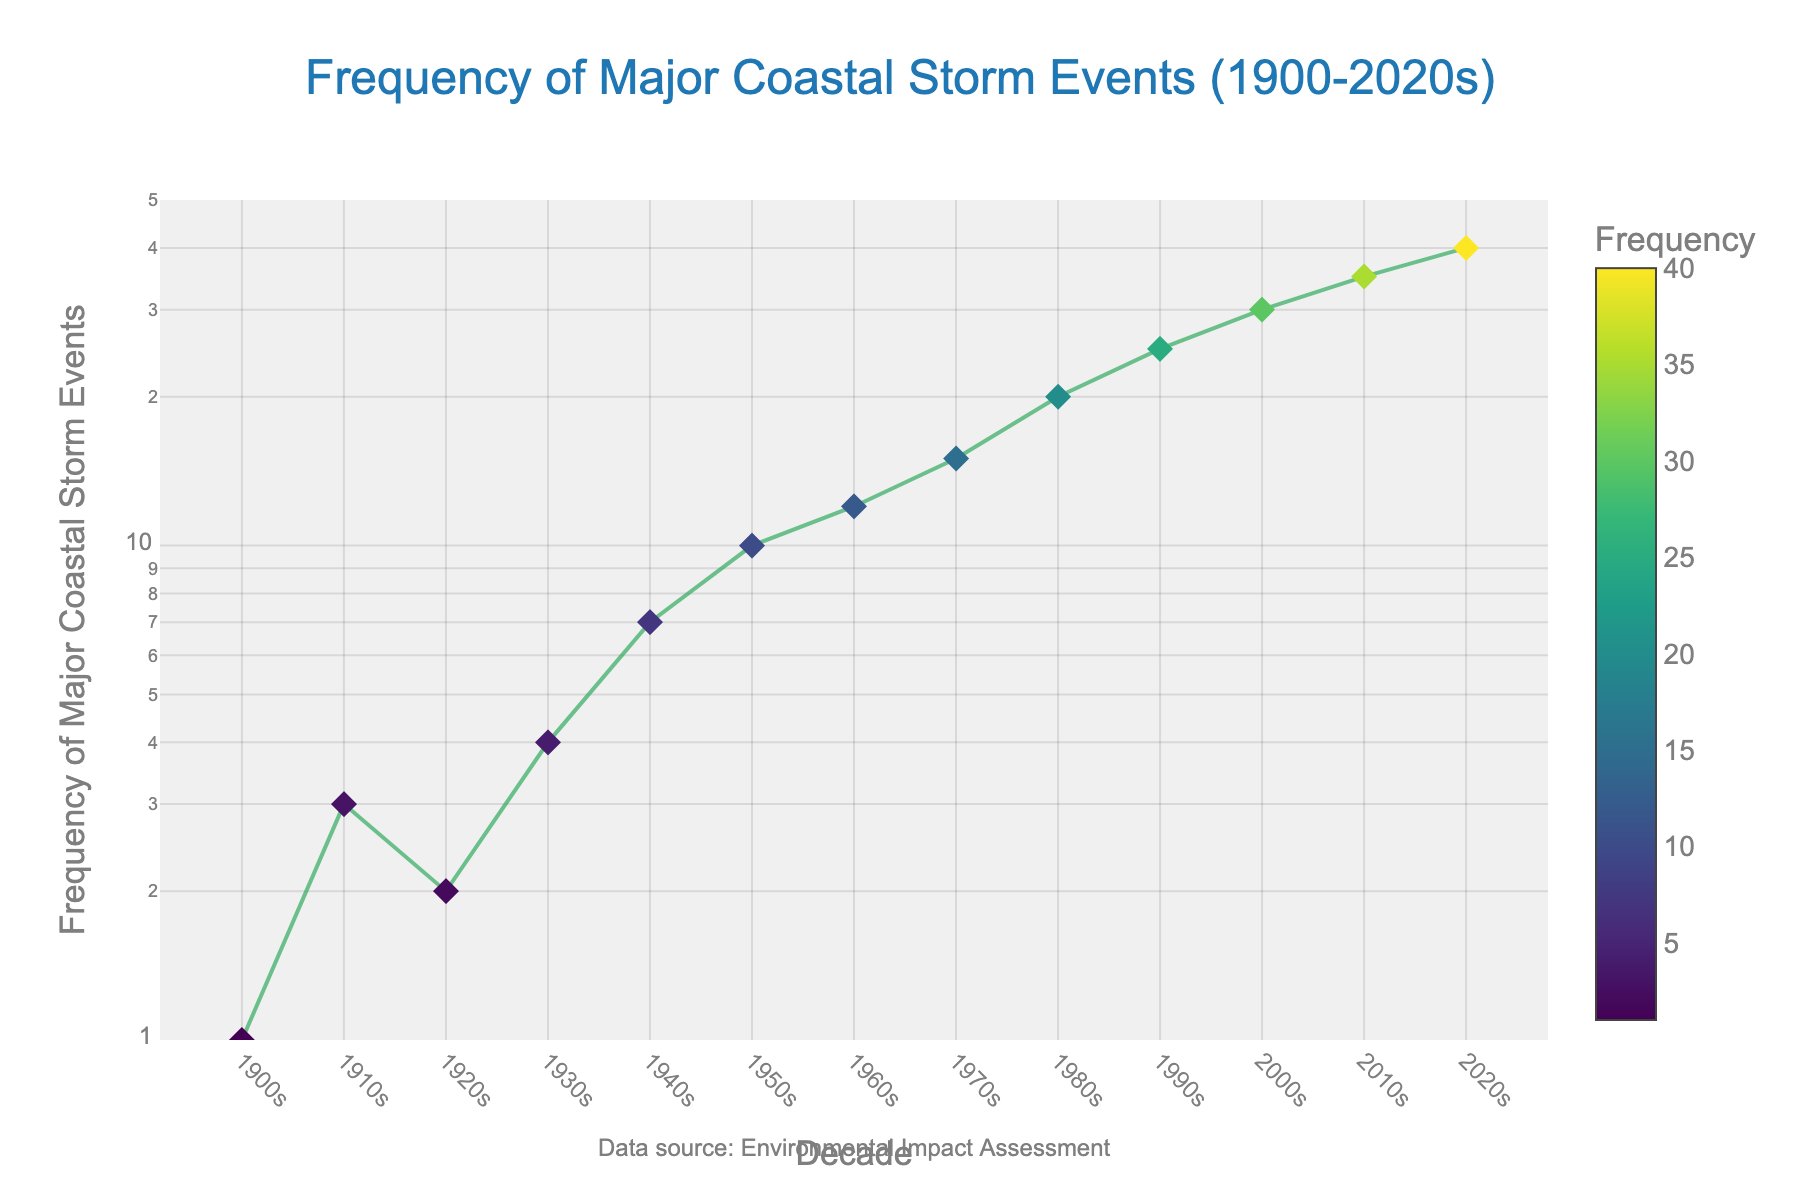How many decades are represented in the figure? There are 13 points on the x-axis, each representing a decade from the 1900s to the 2020s.
Answer: 13 What is the title of the figure? The title is at the top of the plot in a larger font.
Answer: Frequency of Major Coastal Storm Events (1900-2020s) How many storm events were recorded in the 1970s? By looking at the y-value corresponding to the x-value for the 1970s, you can see it is 15.
Answer: 15 In which decade did the frequency of major storm events first reach double digits? The frequency reaches 10 in the 1950s, as indicated by the y-value for that decade.
Answer: 1950s What is the color scheme used for the markers? The color scheme is a Viridis color scale, which is apparent from the gradual change in marker colors as the frequency increases.
Answer: Viridis Which decade had the lowest frequency of major coastal storm events? The y-axis shows the frequency and the lowest recorded value corresponds to the 1900s with a frequency of 1.
Answer: 1900s By what factor did the frequency of storm events increase from the 1900s to the 2020s? The frequency in the 1900s is 1 and in the 2020s it is 40. So, the factor increase is 40 divided by 1.
Answer: 40 What is the general trend observed in the frequency of major coastal storm events over the decades? The plot shows an increasing trend in frequency as the decades progress from 1900s to 2020s.
Answer: Increasing trend Which two consecutive decades show the highest increase in frequency of storm events? The highest increase can be found by comparing the differences between consecutive decades. From 1940s to 1950s, the increase is from 7 to 10, which is the greatest compared to other consecutive pairs.
Answer: 1940s to 1950s Why is a logarithmic scale used for the y-axis? The logarithmic scale is used to accommodate the wide range of storm frequencies, making it easier to visualize the exponential growth in the frequency of events.
Answer: To accommodate wide range and visualize exponential growth 